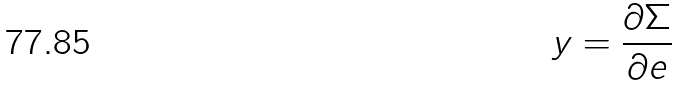Convert formula to latex. <formula><loc_0><loc_0><loc_500><loc_500>y = \frac { \partial \Sigma } { \partial e }</formula> 